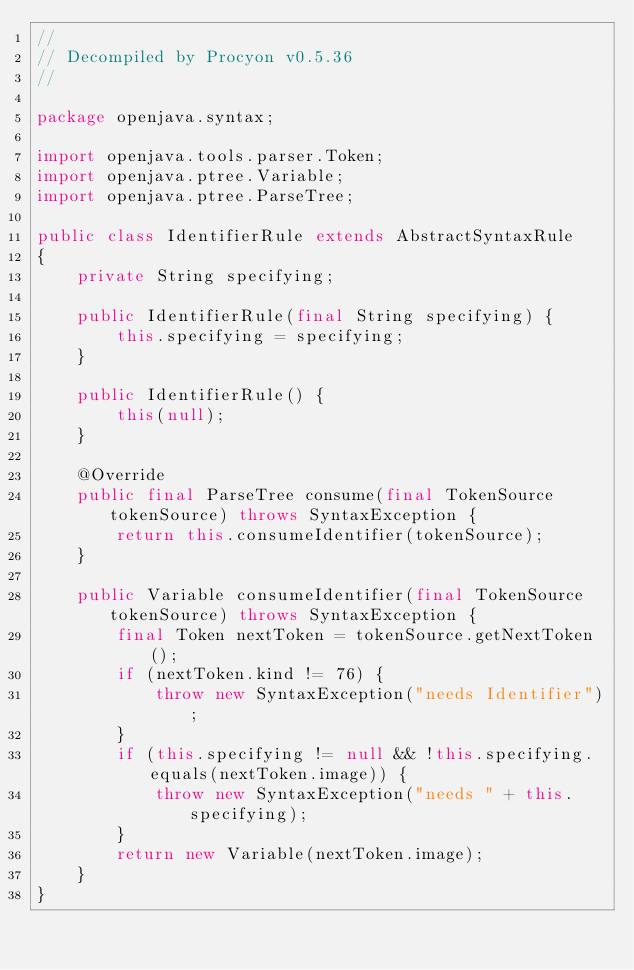<code> <loc_0><loc_0><loc_500><loc_500><_Java_>// 
// Decompiled by Procyon v0.5.36
// 

package openjava.syntax;

import openjava.tools.parser.Token;
import openjava.ptree.Variable;
import openjava.ptree.ParseTree;

public class IdentifierRule extends AbstractSyntaxRule
{
    private String specifying;
    
    public IdentifierRule(final String specifying) {
        this.specifying = specifying;
    }
    
    public IdentifierRule() {
        this(null);
    }
    
    @Override
    public final ParseTree consume(final TokenSource tokenSource) throws SyntaxException {
        return this.consumeIdentifier(tokenSource);
    }
    
    public Variable consumeIdentifier(final TokenSource tokenSource) throws SyntaxException {
        final Token nextToken = tokenSource.getNextToken();
        if (nextToken.kind != 76) {
            throw new SyntaxException("needs Identifier");
        }
        if (this.specifying != null && !this.specifying.equals(nextToken.image)) {
            throw new SyntaxException("needs " + this.specifying);
        }
        return new Variable(nextToken.image);
    }
}
</code> 